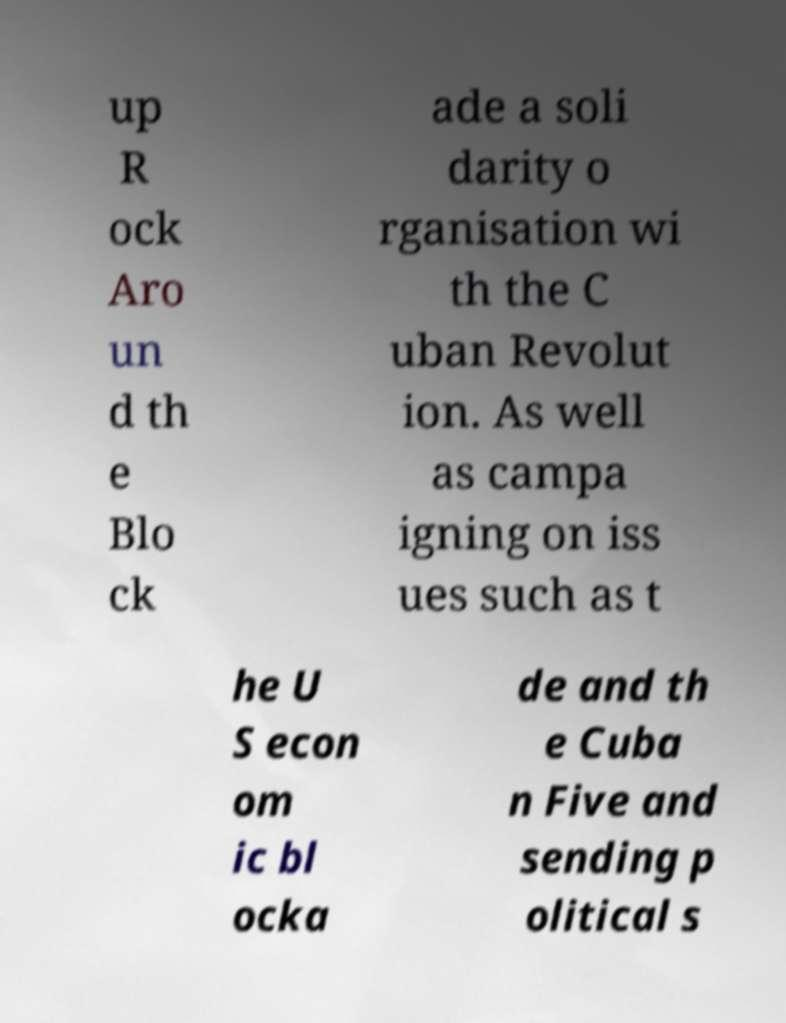For documentation purposes, I need the text within this image transcribed. Could you provide that? up R ock Aro un d th e Blo ck ade a soli darity o rganisation wi th the C uban Revolut ion. As well as campa igning on iss ues such as t he U S econ om ic bl ocka de and th e Cuba n Five and sending p olitical s 